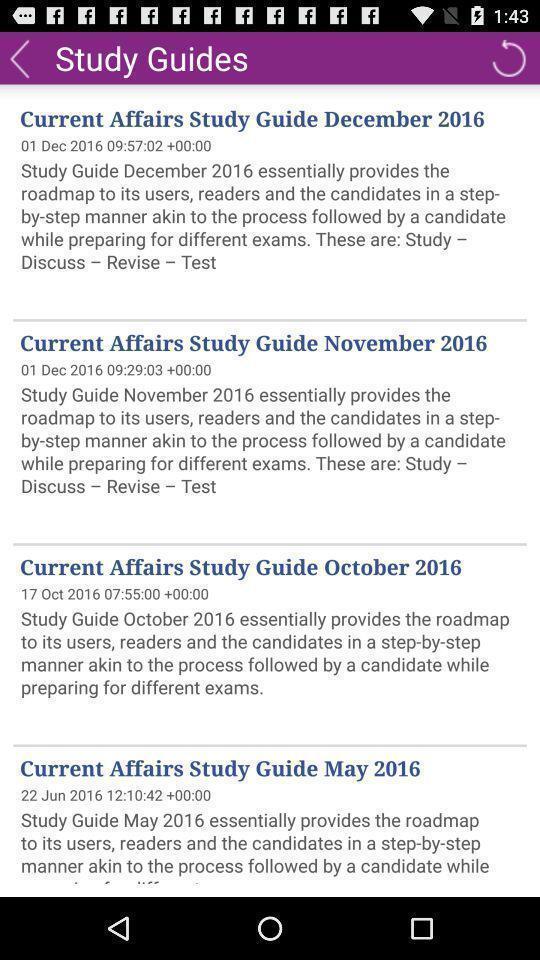Provide a textual representation of this image. Screen shows list of study guides in a learning app. 